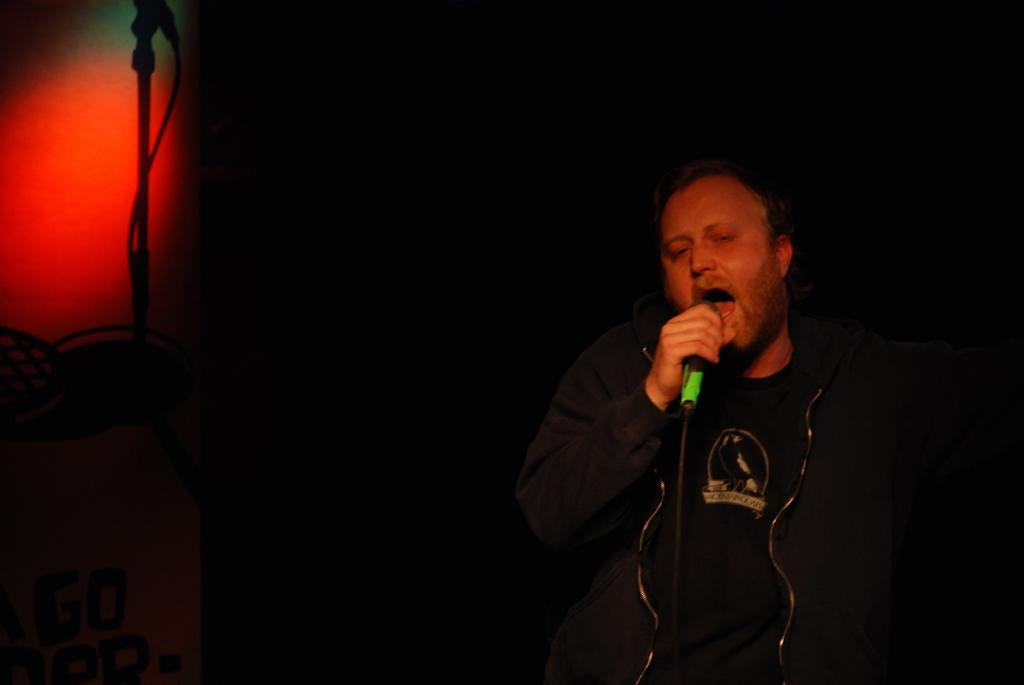What is the main subject of the image? There is a person in the image. What is the person wearing? The person is wearing a blue jacket. What is the person doing in the image? The person is singing. What object is the person holding? The person is holding a microphone. What is the color of the person's face? The person's face is red in color. What color is the background of the image? The background of the image is black. Where is the red color located in the image? There is a red color in the left top corner of the image. What type of bird can be seen flying in the image? There is no bird present in the image. How long does it take for the person to sing a verse in the image? The image does not provide information about the duration of the person's singing. 